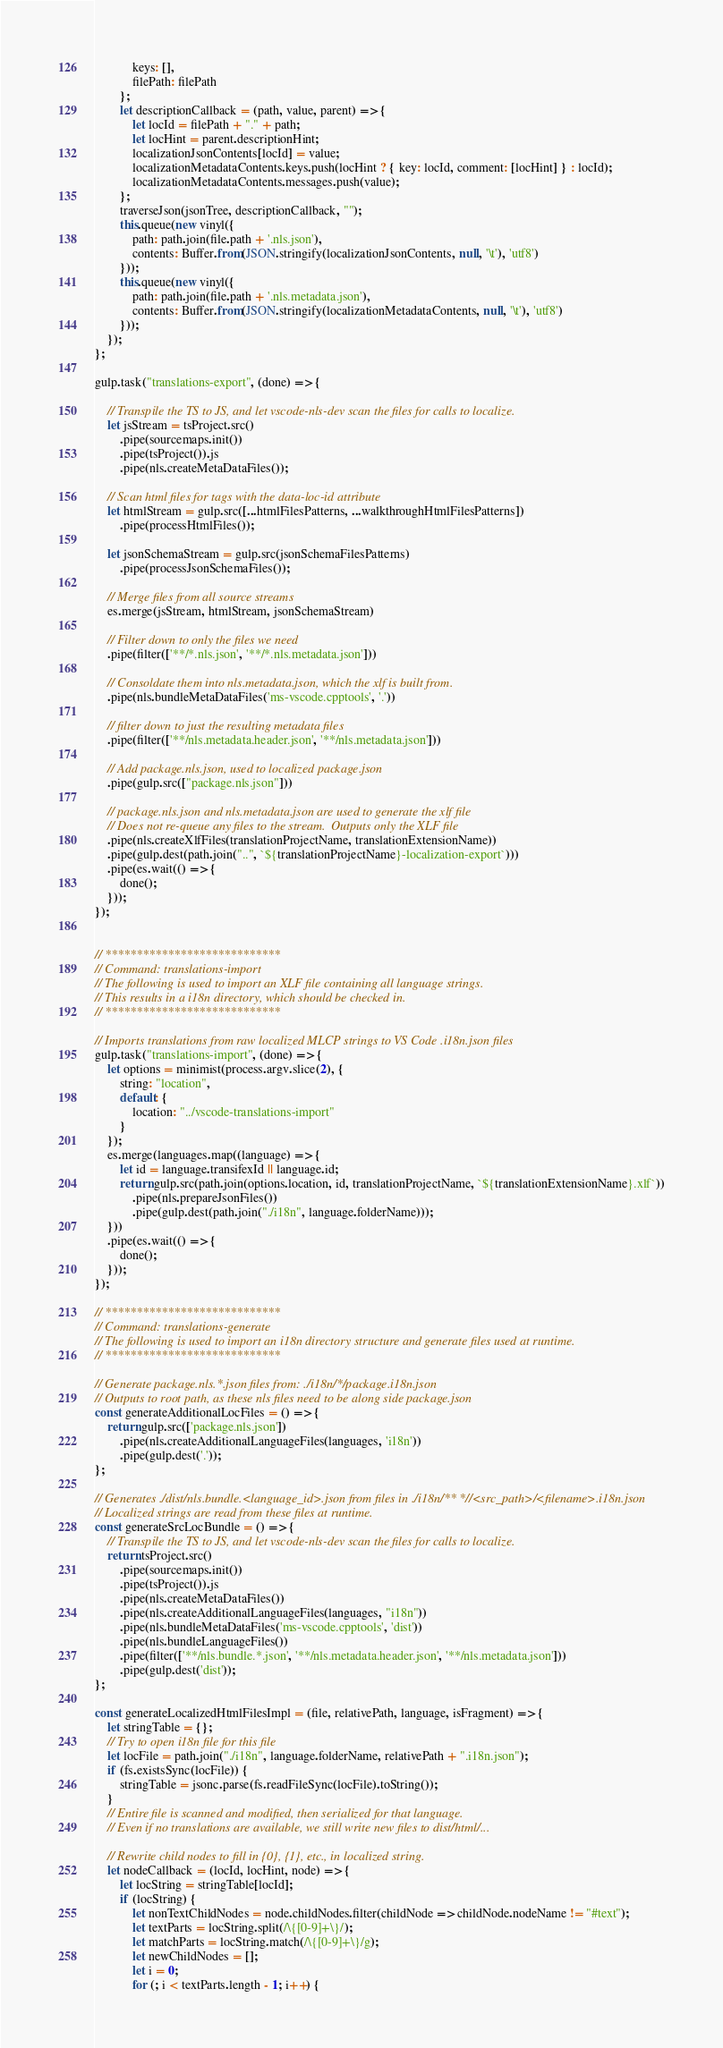<code> <loc_0><loc_0><loc_500><loc_500><_JavaScript_>            keys: [],
            filePath: filePath
        };
        let descriptionCallback = (path, value, parent) => {
            let locId = filePath + "." + path;
            let locHint = parent.descriptionHint;
            localizationJsonContents[locId] = value;
            localizationMetadataContents.keys.push(locHint ? { key: locId, comment: [locHint] } : locId);
            localizationMetadataContents.messages.push(value);
        };
        traverseJson(jsonTree, descriptionCallback, "");
        this.queue(new vinyl({
            path: path.join(file.path + '.nls.json'),
            contents: Buffer.from(JSON.stringify(localizationJsonContents, null, '\t'), 'utf8')
        }));
        this.queue(new vinyl({
            path: path.join(file.path + '.nls.metadata.json'),
            contents: Buffer.from(JSON.stringify(localizationMetadataContents, null, '\t'), 'utf8')
        }));
    });
};

gulp.task("translations-export", (done) => {

    // Transpile the TS to JS, and let vscode-nls-dev scan the files for calls to localize.
    let jsStream = tsProject.src()
        .pipe(sourcemaps.init())
        .pipe(tsProject()).js
        .pipe(nls.createMetaDataFiles());

    // Scan html files for tags with the data-loc-id attribute
    let htmlStream = gulp.src([...htmlFilesPatterns, ...walkthroughHtmlFilesPatterns])
        .pipe(processHtmlFiles());

    let jsonSchemaStream = gulp.src(jsonSchemaFilesPatterns)
        .pipe(processJsonSchemaFiles());

    // Merge files from all source streams
    es.merge(jsStream, htmlStream, jsonSchemaStream)

    // Filter down to only the files we need
    .pipe(filter(['**/*.nls.json', '**/*.nls.metadata.json']))

    // Consoldate them into nls.metadata.json, which the xlf is built from.
    .pipe(nls.bundleMetaDataFiles('ms-vscode.cpptools', '.'))

    // filter down to just the resulting metadata files
    .pipe(filter(['**/nls.metadata.header.json', '**/nls.metadata.json']))

    // Add package.nls.json, used to localized package.json
    .pipe(gulp.src(["package.nls.json"]))

    // package.nls.json and nls.metadata.json are used to generate the xlf file
    // Does not re-queue any files to the stream.  Outputs only the XLF file
    .pipe(nls.createXlfFiles(translationProjectName, translationExtensionName))
    .pipe(gulp.dest(path.join("..", `${translationProjectName}-localization-export`)))
    .pipe(es.wait(() => {
        done();
    }));
});


// ****************************
// Command: translations-import
// The following is used to import an XLF file containing all language strings.
// This results in a i18n directory, which should be checked in.
// ****************************

// Imports translations from raw localized MLCP strings to VS Code .i18n.json files
gulp.task("translations-import", (done) => {
    let options = minimist(process.argv.slice(2), {
        string: "location",
        default: {
            location: "../vscode-translations-import"
        }
    });
    es.merge(languages.map((language) => {
        let id = language.transifexId || language.id;
        return gulp.src(path.join(options.location, id, translationProjectName, `${translationExtensionName}.xlf`))
            .pipe(nls.prepareJsonFiles())
            .pipe(gulp.dest(path.join("./i18n", language.folderName)));
    }))
    .pipe(es.wait(() => {
        done();
    }));
});

// ****************************
// Command: translations-generate
// The following is used to import an i18n directory structure and generate files used at runtime.
// ****************************

// Generate package.nls.*.json files from: ./i18n/*/package.i18n.json
// Outputs to root path, as these nls files need to be along side package.json
const generateAdditionalLocFiles = () => {
    return gulp.src(['package.nls.json'])
        .pipe(nls.createAdditionalLanguageFiles(languages, 'i18n'))
        .pipe(gulp.dest('.'));
};

// Generates ./dist/nls.bundle.<language_id>.json from files in ./i18n/** *//<src_path>/<filename>.i18n.json
// Localized strings are read from these files at runtime.
const generateSrcLocBundle = () => {
    // Transpile the TS to JS, and let vscode-nls-dev scan the files for calls to localize.
    return tsProject.src()
        .pipe(sourcemaps.init())
        .pipe(tsProject()).js
        .pipe(nls.createMetaDataFiles())
        .pipe(nls.createAdditionalLanguageFiles(languages, "i18n"))
        .pipe(nls.bundleMetaDataFiles('ms-vscode.cpptools', 'dist'))
        .pipe(nls.bundleLanguageFiles())
        .pipe(filter(['**/nls.bundle.*.json', '**/nls.metadata.header.json', '**/nls.metadata.json']))
        .pipe(gulp.dest('dist'));
};

const generateLocalizedHtmlFilesImpl = (file, relativePath, language, isFragment) => {
    let stringTable = {};
    // Try to open i18n file for this file
    let locFile = path.join("./i18n", language.folderName, relativePath + ".i18n.json");
    if (fs.existsSync(locFile)) {
        stringTable = jsonc.parse(fs.readFileSync(locFile).toString());
    }
    // Entire file is scanned and modified, then serialized for that language.
    // Even if no translations are available, we still write new files to dist/html/...

    // Rewrite child nodes to fill in {0}, {1}, etc., in localized string.
    let nodeCallback = (locId, locHint, node) => {
        let locString = stringTable[locId];
        if (locString) {
            let nonTextChildNodes = node.childNodes.filter(childNode => childNode.nodeName != "#text");
            let textParts = locString.split(/\{[0-9]+\}/);
            let matchParts = locString.match(/\{[0-9]+\}/g);
            let newChildNodes = [];
            let i = 0;
            for (; i < textParts.length - 1; i++) {</code> 